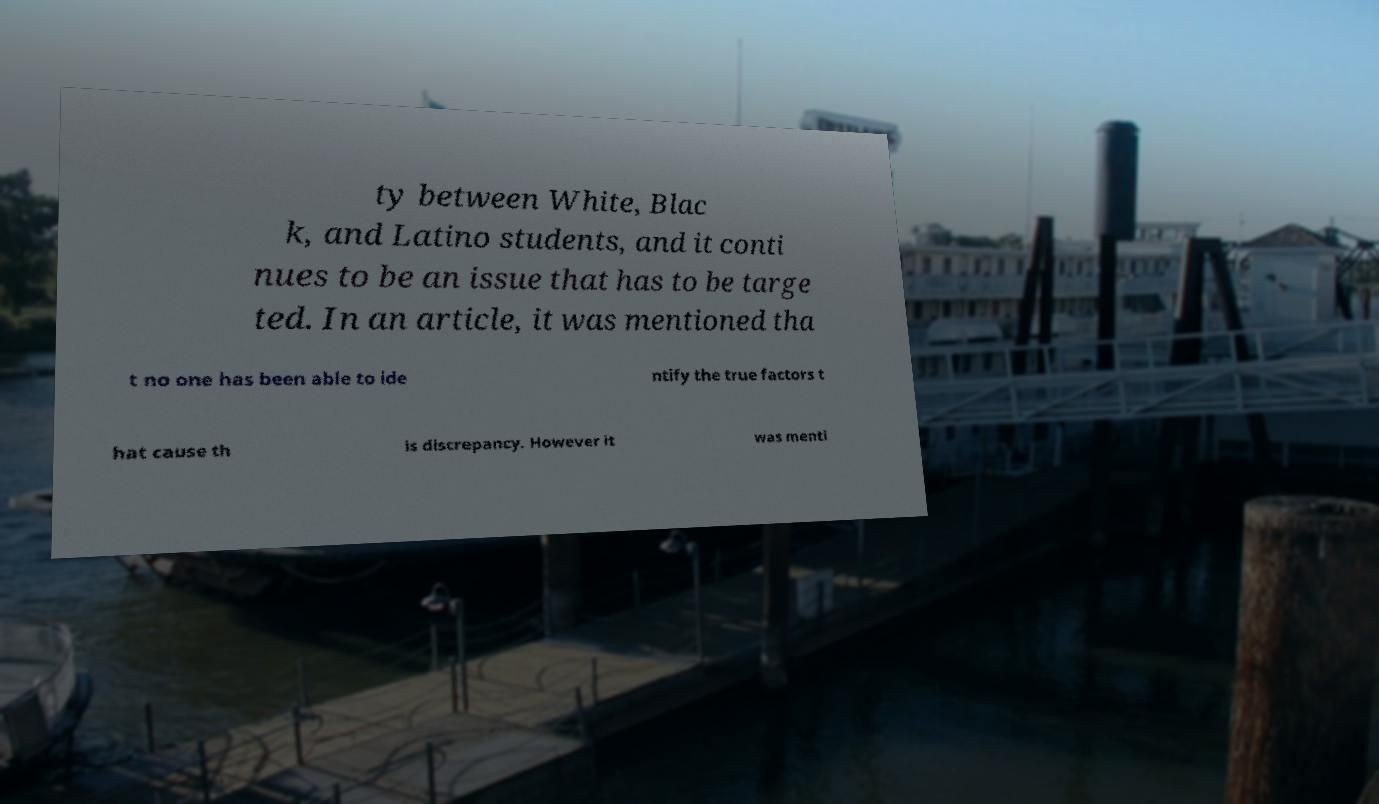I need the written content from this picture converted into text. Can you do that? ty between White, Blac k, and Latino students, and it conti nues to be an issue that has to be targe ted. In an article, it was mentioned tha t no one has been able to ide ntify the true factors t hat cause th is discrepancy. However it was menti 